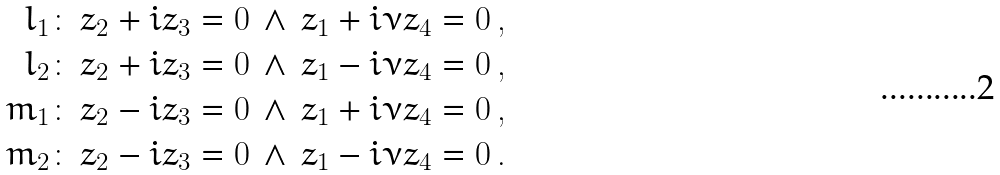Convert formula to latex. <formula><loc_0><loc_0><loc_500><loc_500>l _ { 1 } & \colon \, z _ { 2 } + i z _ { 3 } = 0 \, \wedge \, z _ { 1 } + i \nu z _ { 4 } = 0 \, , \\ l _ { 2 } & \colon \, z _ { 2 } + i z _ { 3 } = 0 \, \wedge \, z _ { 1 } - i \nu z _ { 4 } = 0 \, , \\ m _ { 1 } & \colon \, z _ { 2 } - i z _ { 3 } = 0 \, \wedge \, z _ { 1 } + i \nu z _ { 4 } = 0 \, , \\ m _ { 2 } & \colon \, z _ { 2 } - i z _ { 3 } = 0 \, \wedge \, z _ { 1 } - i \nu z _ { 4 } = 0 \, .</formula> 